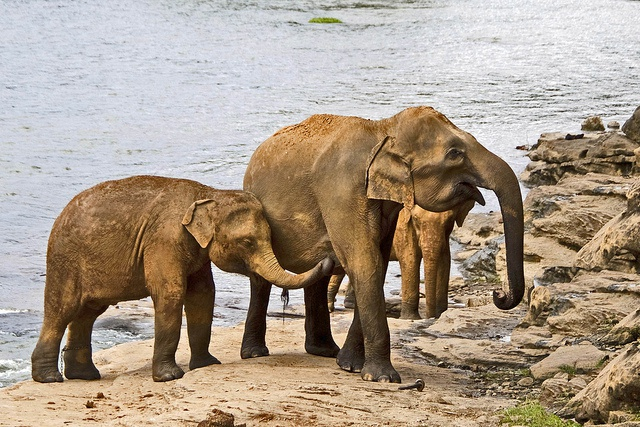Describe the objects in this image and their specific colors. I can see elephant in lightgray, black, gray, maroon, and tan tones, elephant in lightgray, maroon, black, gray, and olive tones, and elephant in lightgray, black, olive, and maroon tones in this image. 